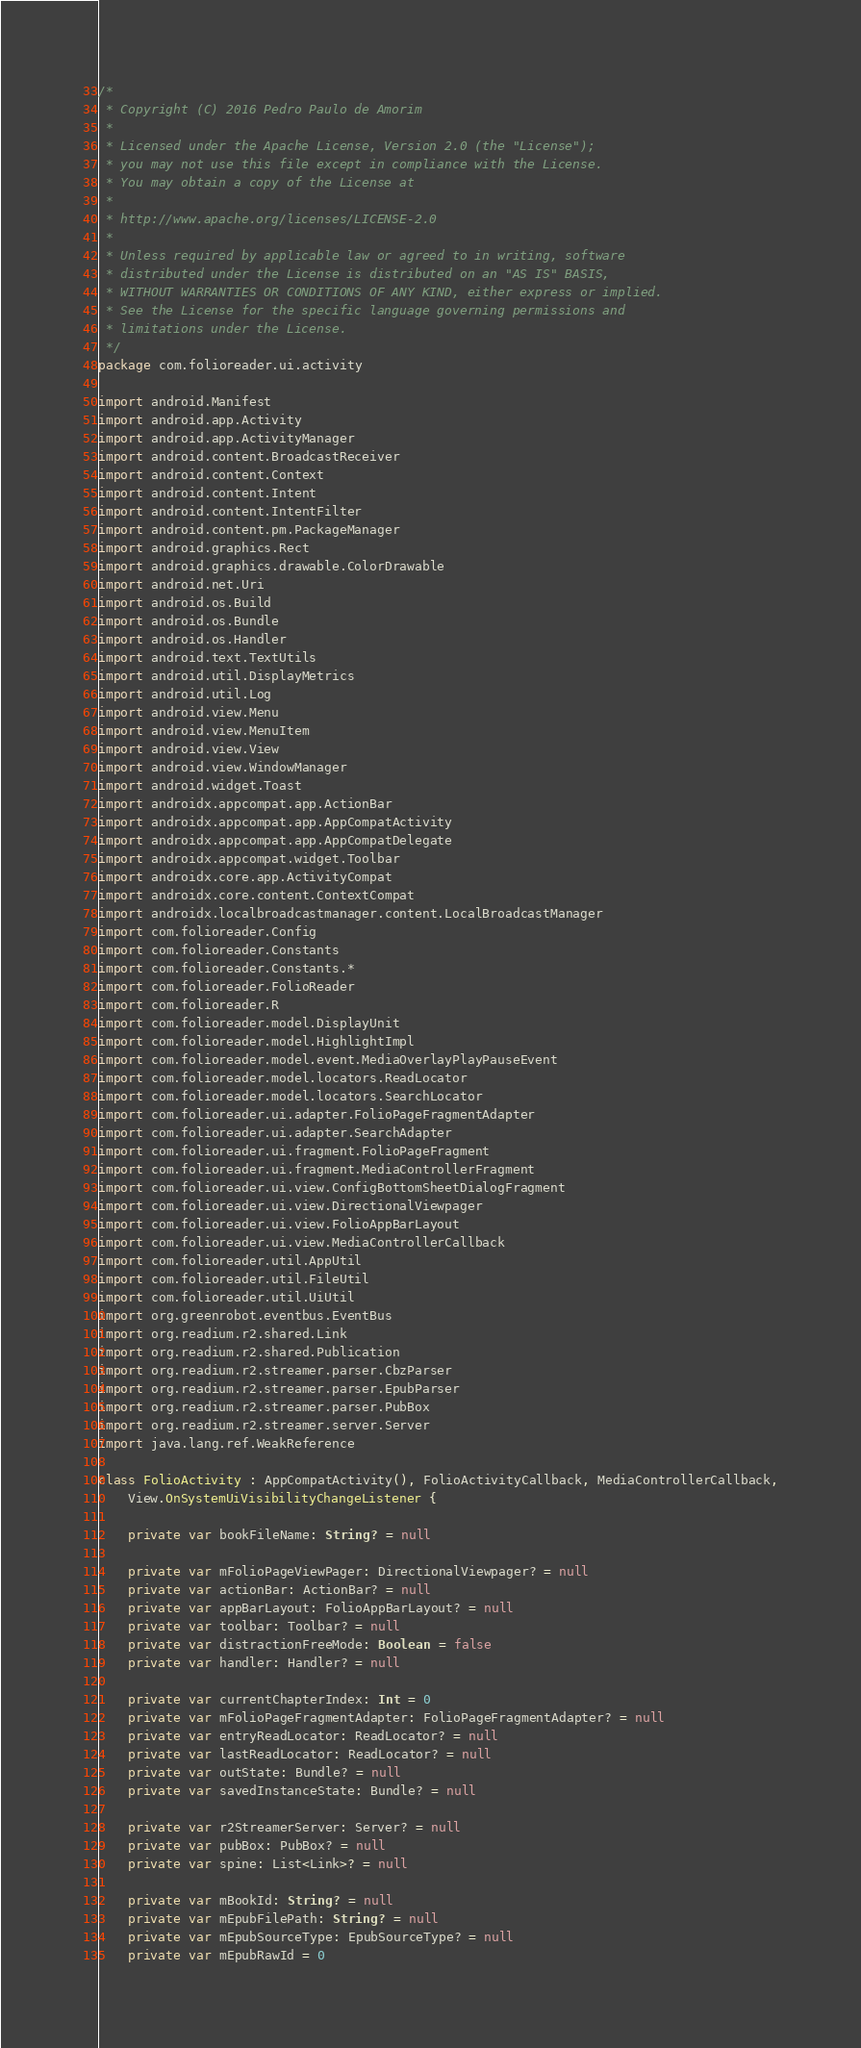Convert code to text. <code><loc_0><loc_0><loc_500><loc_500><_Kotlin_>/*
 * Copyright (C) 2016 Pedro Paulo de Amorim
 *
 * Licensed under the Apache License, Version 2.0 (the "License");
 * you may not use this file except in compliance with the License.
 * You may obtain a copy of the License at
 *
 * http://www.apache.org/licenses/LICENSE-2.0
 *
 * Unless required by applicable law or agreed to in writing, software
 * distributed under the License is distributed on an "AS IS" BASIS,
 * WITHOUT WARRANTIES OR CONDITIONS OF ANY KIND, either express or implied.
 * See the License for the specific language governing permissions and
 * limitations under the License.
 */
package com.folioreader.ui.activity

import android.Manifest
import android.app.Activity
import android.app.ActivityManager
import android.content.BroadcastReceiver
import android.content.Context
import android.content.Intent
import android.content.IntentFilter
import android.content.pm.PackageManager
import android.graphics.Rect
import android.graphics.drawable.ColorDrawable
import android.net.Uri
import android.os.Build
import android.os.Bundle
import android.os.Handler
import android.text.TextUtils
import android.util.DisplayMetrics
import android.util.Log
import android.view.Menu
import android.view.MenuItem
import android.view.View
import android.view.WindowManager
import android.widget.Toast
import androidx.appcompat.app.ActionBar
import androidx.appcompat.app.AppCompatActivity
import androidx.appcompat.app.AppCompatDelegate
import androidx.appcompat.widget.Toolbar
import androidx.core.app.ActivityCompat
import androidx.core.content.ContextCompat
import androidx.localbroadcastmanager.content.LocalBroadcastManager
import com.folioreader.Config
import com.folioreader.Constants
import com.folioreader.Constants.*
import com.folioreader.FolioReader
import com.folioreader.R
import com.folioreader.model.DisplayUnit
import com.folioreader.model.HighlightImpl
import com.folioreader.model.event.MediaOverlayPlayPauseEvent
import com.folioreader.model.locators.ReadLocator
import com.folioreader.model.locators.SearchLocator
import com.folioreader.ui.adapter.FolioPageFragmentAdapter
import com.folioreader.ui.adapter.SearchAdapter
import com.folioreader.ui.fragment.FolioPageFragment
import com.folioreader.ui.fragment.MediaControllerFragment
import com.folioreader.ui.view.ConfigBottomSheetDialogFragment
import com.folioreader.ui.view.DirectionalViewpager
import com.folioreader.ui.view.FolioAppBarLayout
import com.folioreader.ui.view.MediaControllerCallback
import com.folioreader.util.AppUtil
import com.folioreader.util.FileUtil
import com.folioreader.util.UiUtil
import org.greenrobot.eventbus.EventBus
import org.readium.r2.shared.Link
import org.readium.r2.shared.Publication
import org.readium.r2.streamer.parser.CbzParser
import org.readium.r2.streamer.parser.EpubParser
import org.readium.r2.streamer.parser.PubBox
import org.readium.r2.streamer.server.Server
import java.lang.ref.WeakReference

class FolioActivity : AppCompatActivity(), FolioActivityCallback, MediaControllerCallback,
    View.OnSystemUiVisibilityChangeListener {

    private var bookFileName: String? = null

    private var mFolioPageViewPager: DirectionalViewpager? = null
    private var actionBar: ActionBar? = null
    private var appBarLayout: FolioAppBarLayout? = null
    private var toolbar: Toolbar? = null
    private var distractionFreeMode: Boolean = false
    private var handler: Handler? = null

    private var currentChapterIndex: Int = 0
    private var mFolioPageFragmentAdapter: FolioPageFragmentAdapter? = null
    private var entryReadLocator: ReadLocator? = null
    private var lastReadLocator: ReadLocator? = null
    private var outState: Bundle? = null
    private var savedInstanceState: Bundle? = null

    private var r2StreamerServer: Server? = null
    private var pubBox: PubBox? = null
    private var spine: List<Link>? = null

    private var mBookId: String? = null
    private var mEpubFilePath: String? = null
    private var mEpubSourceType: EpubSourceType? = null
    private var mEpubRawId = 0</code> 